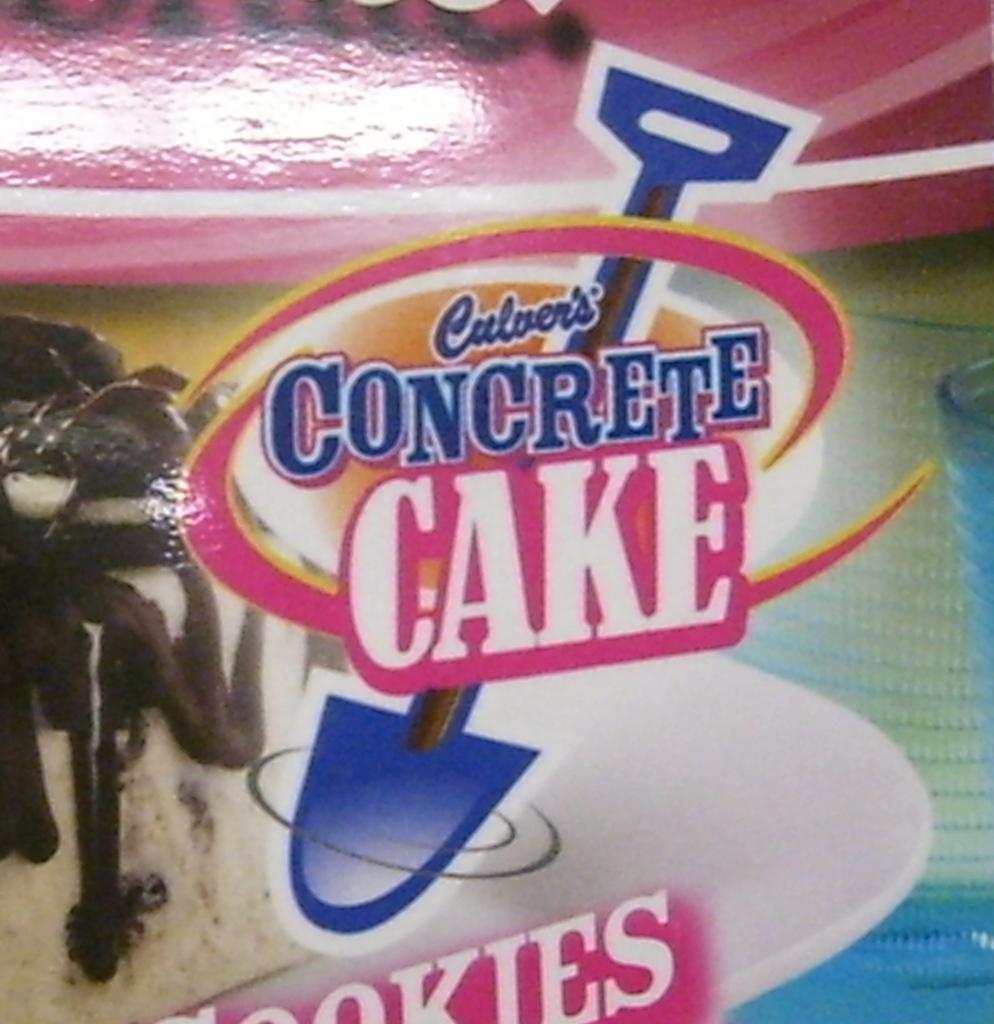Please provide a concise description of this image. In this image we can see the wrapper of a packed food. 